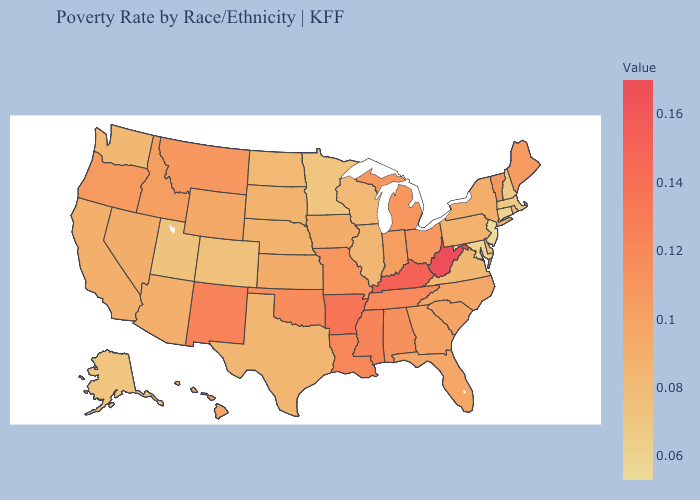Does Texas have a higher value than Missouri?
Answer briefly. No. Does the map have missing data?
Write a very short answer. No. Is the legend a continuous bar?
Keep it brief. Yes. Does Arkansas have the highest value in the South?
Give a very brief answer. No. Among the states that border New Mexico , does Oklahoma have the lowest value?
Keep it brief. No. Among the states that border New York , which have the highest value?
Short answer required. Vermont. 